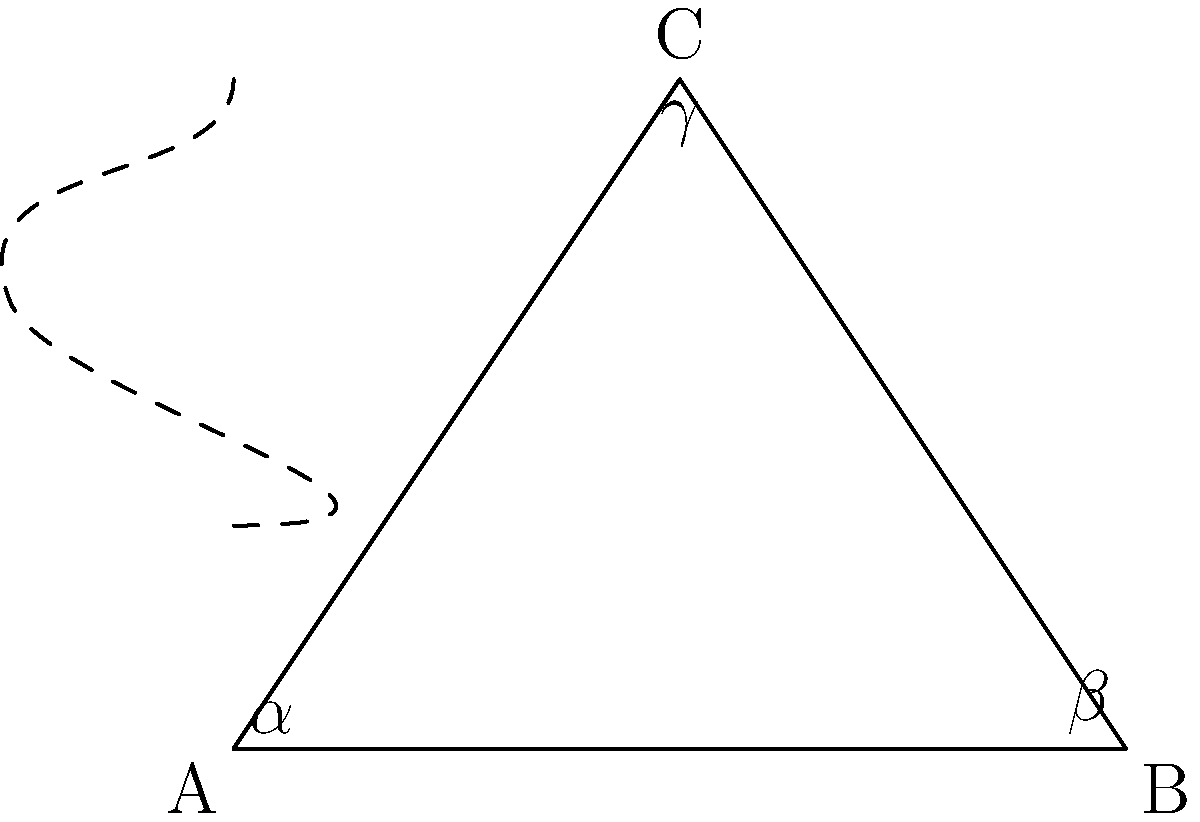In hyperbolic geometry, how does the sum of the angles in a triangle compare to that in Euclidean geometry? Provide a formula for the sum of angles in a hyperbolic triangle and explain its significance. To understand the difference between hyperbolic and Euclidean geometry regarding the sum of angles in a triangle:

1. Euclidean geometry:
   - In Euclidean geometry, the sum of angles in a triangle is always 180°, or $\pi$ radians.
   - Formula: $\alpha + \beta + \gamma = \pi$

2. Hyperbolic geometry:
   - In hyperbolic geometry, the sum of angles in a triangle is always less than 180°, or $\pi$ radians.
   - Formula: $\alpha + \beta + \gamma = \pi - A$, where $A$ is the area of the triangle

3. The defect:
   - The difference between $\pi$ and the sum of angles in a hyperbolic triangle is called the defect.
   - Defect = $\pi - (\alpha + \beta + \gamma) = A$

4. Significance:
   - This relationship shows that in hyperbolic geometry, the area of a triangle is directly related to its angle sum.
   - Larger triangles have a greater defect, meaning their angles sum to a smaller value.
   - There is no similar triangle in hyperbolic geometry, as changing the size changes the angles.

5. Gauss-Bonnet theorem:
   - This concept is generalized by the Gauss-Bonnet theorem, which relates the geometry of a surface to its topology.
   - For a hyperbolic surface with constant curvature $K$: $\alpha + \beta + \gamma = \pi + KA$

The formula $\alpha + \beta + \gamma = \pi - A$ demonstrates the fundamental difference between Euclidean and hyperbolic geometries, showcasing how spatial curvature affects geometric properties.
Answer: $\alpha + \beta + \gamma = \pi - A$, where $A$ is the triangle's area. Always less than $\pi$. 